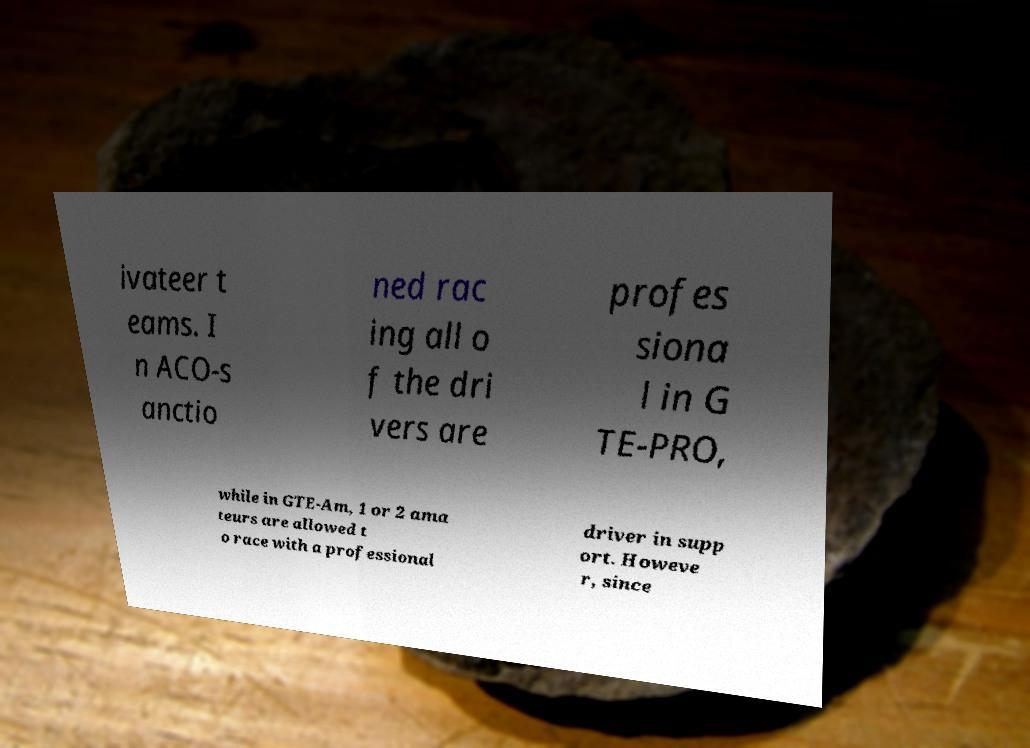Please read and relay the text visible in this image. What does it say? ivateer t eams. I n ACO-s anctio ned rac ing all o f the dri vers are profes siona l in G TE-PRO, while in GTE-Am, 1 or 2 ama teurs are allowed t o race with a professional driver in supp ort. Howeve r, since 